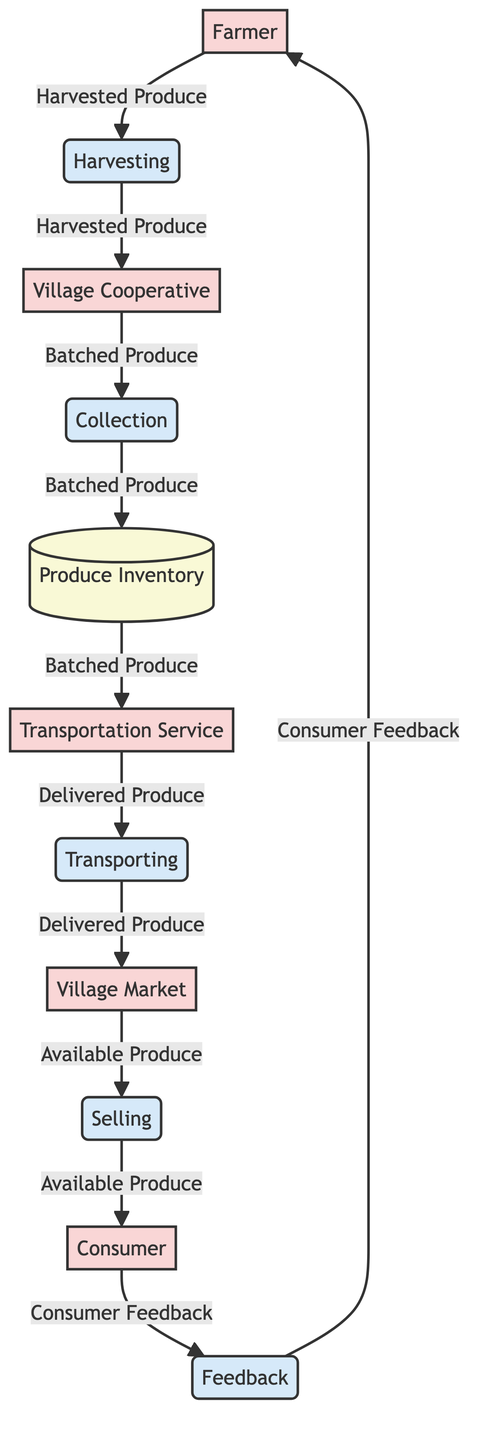What is the first process in the flow? The first process in the flow is "Harvesting." It follows the flow from the Farmer node indicating the initiation of agricultural produce collection.
Answer: Harvesting How many entities are present in the diagram? To determine the number of entities, I count the distinct nodes labeled as entities in the diagram. There are five entities: Farmer, Village Cooperative, Transportation Service, Village Market, and Consumer.
Answer: 5 What information flows from the Village Cooperative to the Transportation Service? The information flowing from the Village Cooperative to the Transportation Service is labeled as "Batched Produce." This indicates processed produce ready for transportation.
Answer: Batched Produce Which node receives feedback from the Consumer? The node that receives feedback from the Consumer is the Farmer. The flow indicates that Consumer Feedback goes back to the Farmer, highlighting a relationship.
Answer: Farmer What is stored in the Produce Inventory? The Produce Inventory stores "Batched Produce." This refers to the aggregated agricultural products collected from multiple farmers, ready for transportation.
Answer: Batched Produce What process follows the "Transporting" process? The process that follows "Transporting" is "Selling." After the delivered produce reaches the Village Market, it enters the selling phase where market vendors sell it to consumers.
Answer: Selling Where does the Consumer purchase the agricultural products? The Consumer purchases the agricultural products at the Village Market. This is clearly indicated in the flow from the Village Market to Consumer under the Selling process.
Answer: Village Market What is the last data flow in the diagram? The last data flow in the diagram is from Consumer to Farmer, labeled as "Consumer Feedback." This feedback loop is essential for the Farmer to understand consumer satisfaction.
Answer: Consumer Feedback How many processes are depicted in the diagram? By counting the distinct processes listed in the diagram, I find there are five processes: Harvesting, Collection, Transporting, Selling, and Feedback.
Answer: 5 